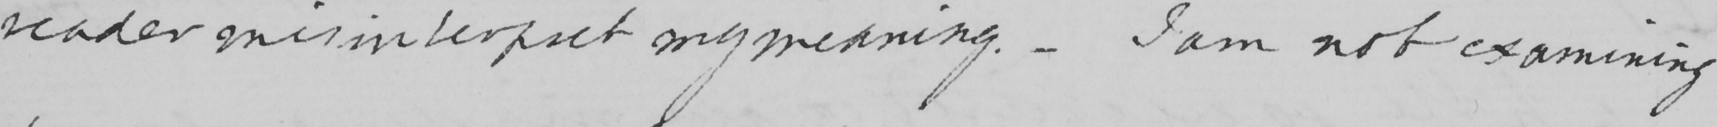What does this handwritten line say? reader misinterpret my meaning .  _  I am not examining 